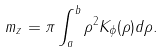Convert formula to latex. <formula><loc_0><loc_0><loc_500><loc_500>m _ { z } = \pi \int _ { a } ^ { b } \rho ^ { 2 } K _ { \phi } ( \rho ) d \rho .</formula> 